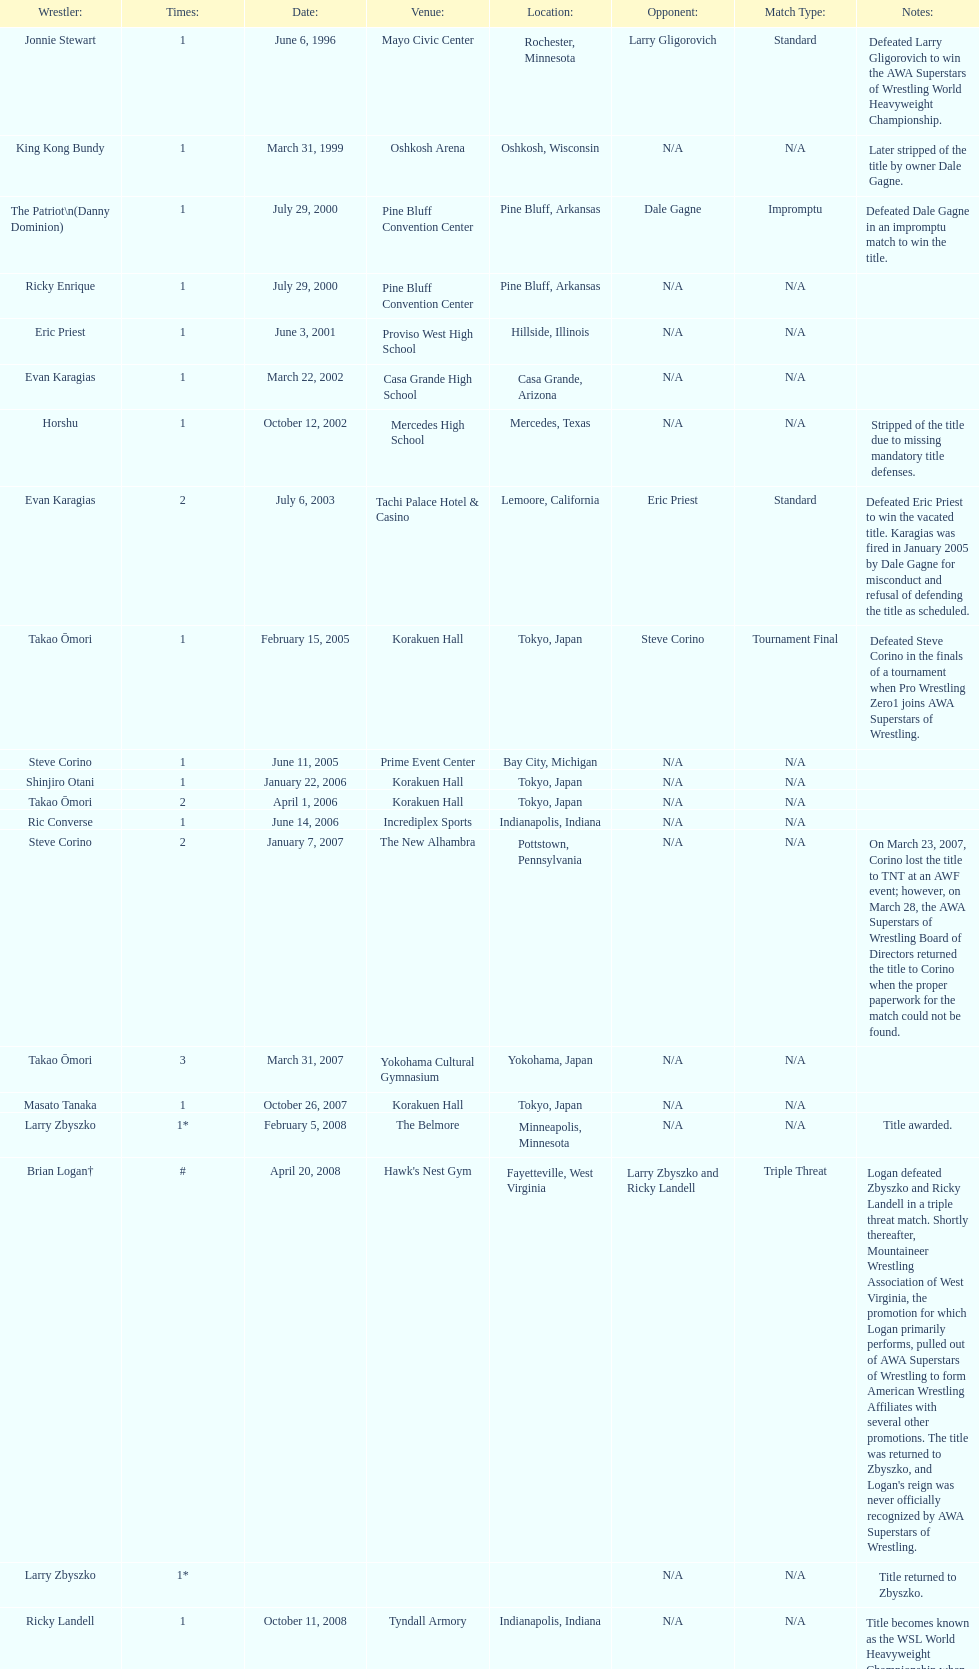How many different men held the wsl title before horshu won his first wsl title? 6. 